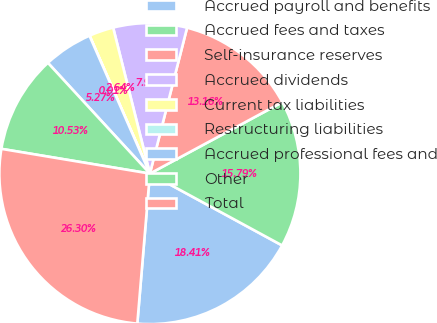<chart> <loc_0><loc_0><loc_500><loc_500><pie_chart><fcel>Accrued payroll and benefits<fcel>Accrued fees and taxes<fcel>Self-insurance reserves<fcel>Accrued dividends<fcel>Current tax liabilities<fcel>Restructuring liabilities<fcel>Accrued professional fees and<fcel>Other<fcel>Total<nl><fcel>18.41%<fcel>15.79%<fcel>13.16%<fcel>7.9%<fcel>2.64%<fcel>0.01%<fcel>5.27%<fcel>10.53%<fcel>26.3%<nl></chart> 